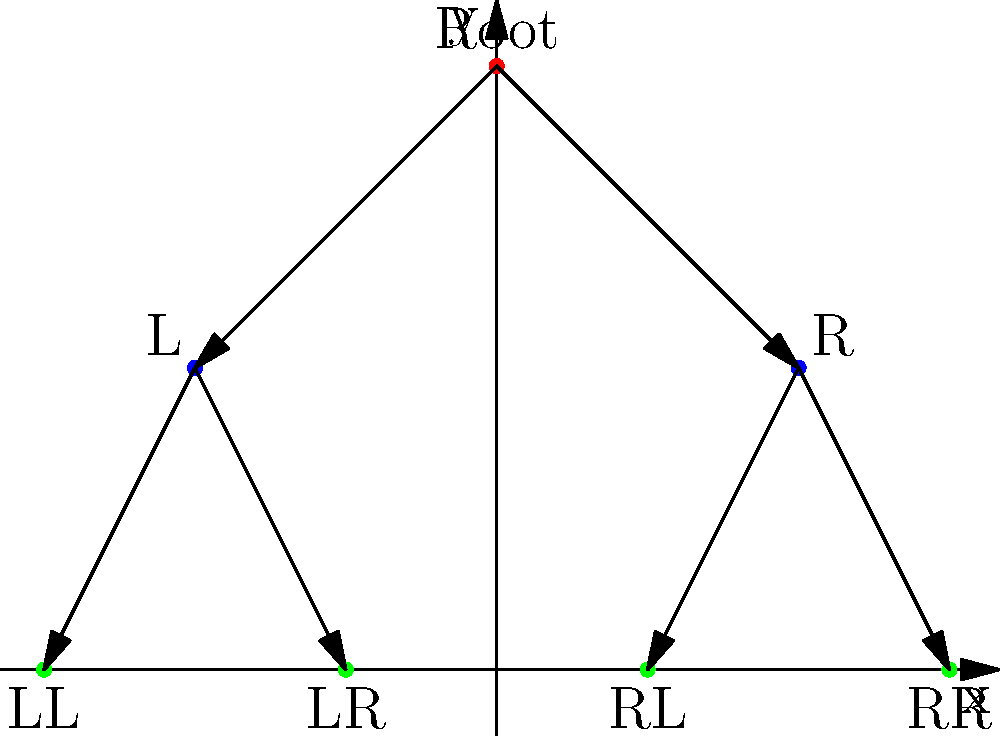In the context of visualizing data structures for beginner programmers, the above diagram represents a binary tree plotted on a 2D coordinate plane. What is the total number of edges in this binary tree representation? To determine the number of edges in the binary tree representation, we need to follow these steps:

1. Identify the nodes: There are 7 nodes in total (1 root, 2 at the second level, and 4 at the third level).

2. Understand the structure: In a binary tree, each node (except leaf nodes) has at most two children, connected by edges.

3. Count the edges:
   - From the root (0,4) to its left child (-2,2): 1 edge
   - From the root (0,4) to its right child (2,2): 1 edge
   - From the left child (-2,2) to its left child (-3,0): 1 edge
   - From the left child (-2,2) to its right child (-1,0): 1 edge
   - From the right child (2,2) to its left child (1,0): 1 edge
   - From the right child (2,2) to its right child (3,0): 1 edge

4. Sum up the edges: 1 + 1 + 1 + 1 + 1 + 1 = 6 edges in total

Therefore, the total number of edges in this binary tree representation is 6.
Answer: 6 